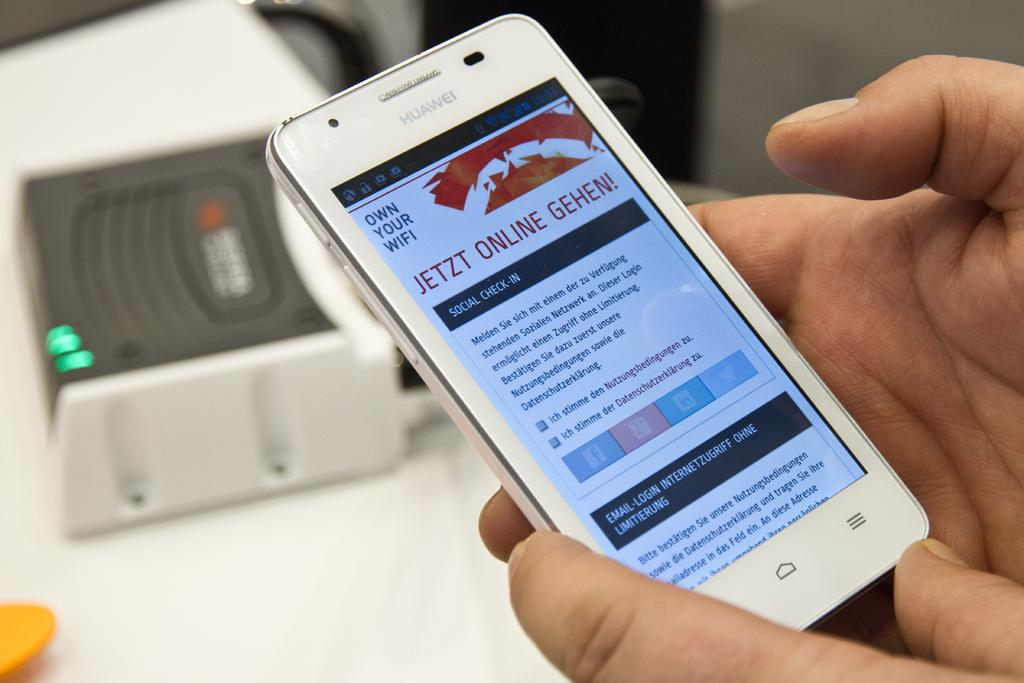<image>
Create a compact narrative representing the image presented. Several different options are listed on the cell phone screen to check-in or login with email and social media. 